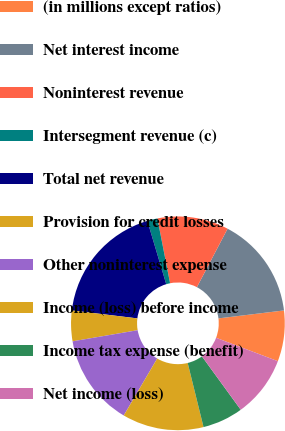Convert chart. <chart><loc_0><loc_0><loc_500><loc_500><pie_chart><fcel>(in millions except ratios)<fcel>Net interest income<fcel>Noninterest revenue<fcel>Intersegment revenue (c)<fcel>Total net revenue<fcel>Provision for credit losses<fcel>Other noninterest expense<fcel>Income (loss) before income<fcel>Income tax expense (benefit)<fcel>Net income (loss)<nl><fcel>7.69%<fcel>15.38%<fcel>10.77%<fcel>1.54%<fcel>18.46%<fcel>4.62%<fcel>13.85%<fcel>12.31%<fcel>6.15%<fcel>9.23%<nl></chart> 